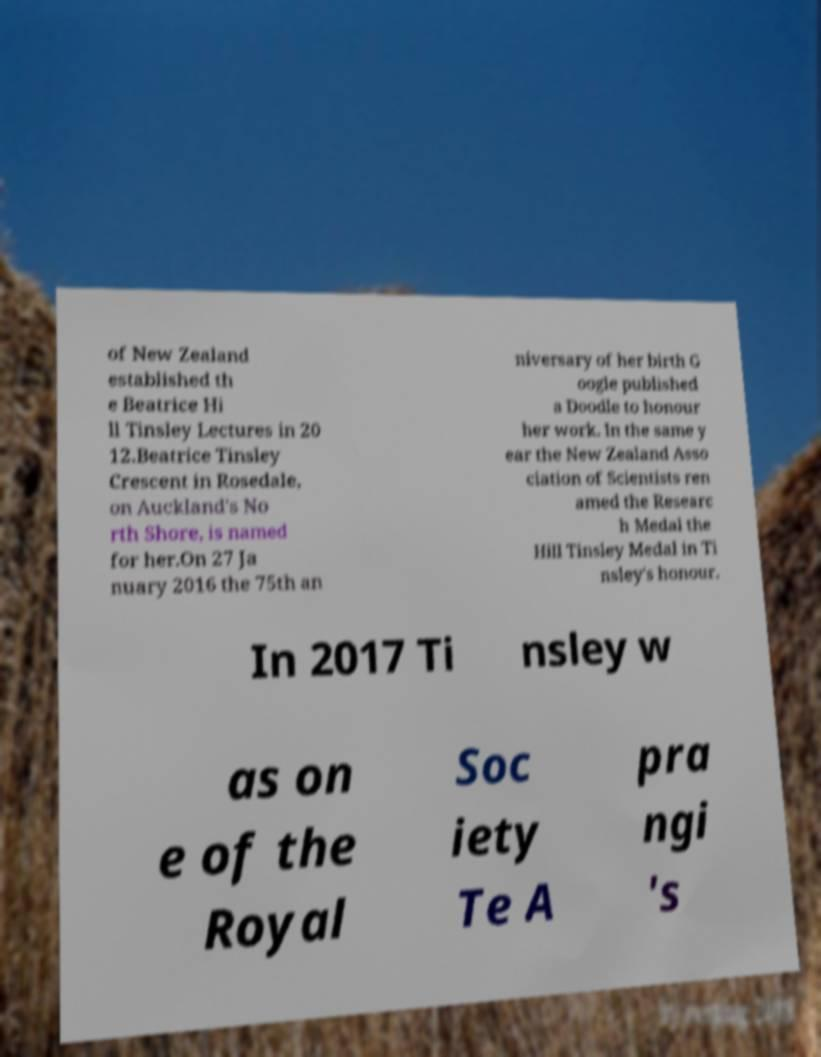Can you read and provide the text displayed in the image?This photo seems to have some interesting text. Can you extract and type it out for me? of New Zealand established th e Beatrice Hi ll Tinsley Lectures in 20 12.Beatrice Tinsley Crescent in Rosedale, on Auckland's No rth Shore, is named for her.On 27 Ja nuary 2016 the 75th an niversary of her birth G oogle published a Doodle to honour her work. In the same y ear the New Zealand Asso ciation of Scientists ren amed the Researc h Medal the Hill Tinsley Medal in Ti nsley's honour. In 2017 Ti nsley w as on e of the Royal Soc iety Te A pra ngi 's 